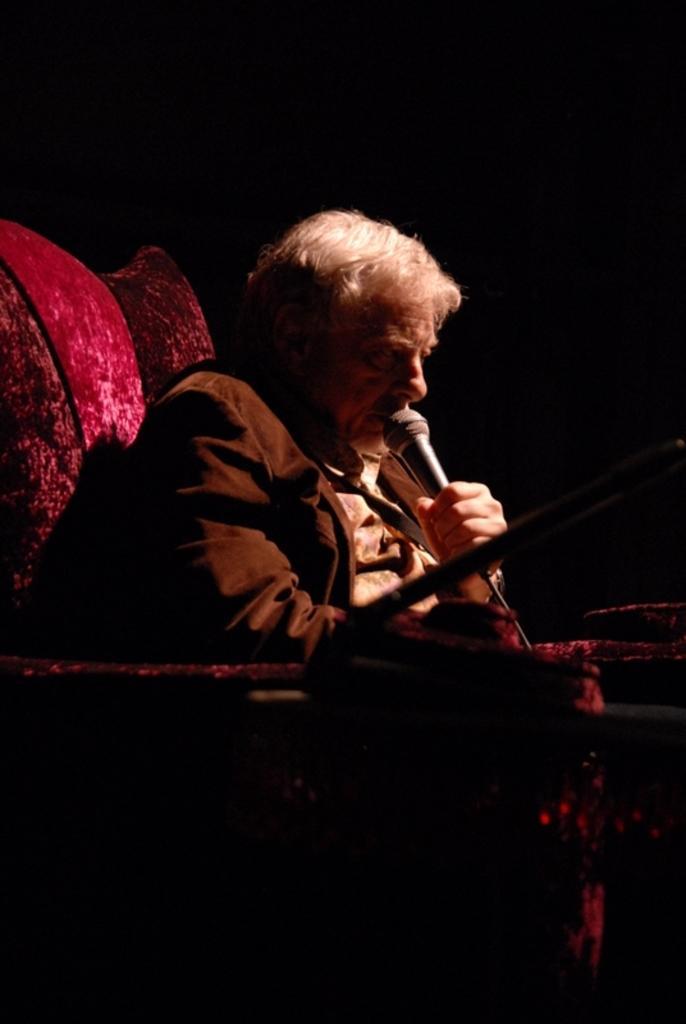Please provide a concise description of this image. In this image there is a man sitting on a couch. He is holding a microphone in his hand. The background is dark. 